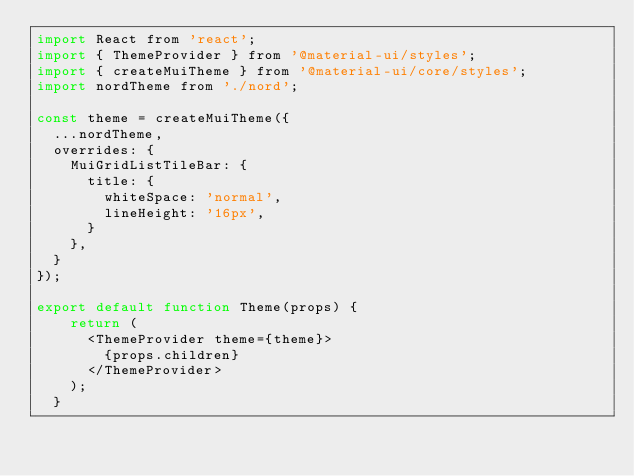Convert code to text. <code><loc_0><loc_0><loc_500><loc_500><_JavaScript_>import React from 'react';
import { ThemeProvider } from '@material-ui/styles';
import { createMuiTheme } from '@material-ui/core/styles';
import nordTheme from './nord';

const theme = createMuiTheme({
  ...nordTheme,
  overrides: {
    MuiGridListTileBar: {
      title: {
        whiteSpace: 'normal',
        lineHeight: '16px',
      }
    },
  }
});

export default function Theme(props) {
    return (
      <ThemeProvider theme={theme}>
        {props.children}
      </ThemeProvider>
    );
  }</code> 